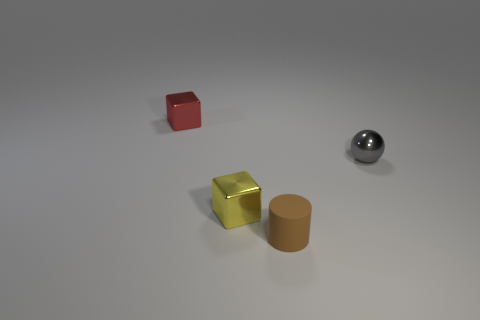Add 2 cylinders. How many objects exist? 6 Subtract all cylinders. How many objects are left? 3 Subtract all red metallic objects. Subtract all tiny red cubes. How many objects are left? 2 Add 4 red objects. How many red objects are left? 5 Add 1 big green rubber things. How many big green rubber things exist? 1 Subtract 1 gray balls. How many objects are left? 3 